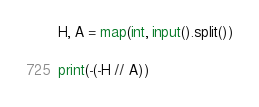<code> <loc_0><loc_0><loc_500><loc_500><_Python_>H, A = map(int, input().split())

print(-(-H // A))</code> 